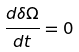Convert formula to latex. <formula><loc_0><loc_0><loc_500><loc_500>\frac { d \delta \Omega } { d t } = 0</formula> 